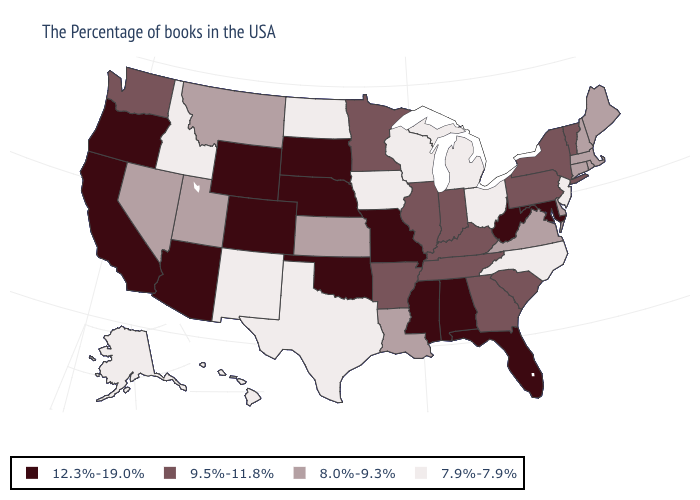What is the value of Wisconsin?
Answer briefly. 7.9%-7.9%. What is the value of North Dakota?
Short answer required. 7.9%-7.9%. Does Vermont have the highest value in the Northeast?
Give a very brief answer. Yes. Does California have a higher value than Maryland?
Keep it brief. No. What is the value of Indiana?
Answer briefly. 9.5%-11.8%. Name the states that have a value in the range 9.5%-11.8%?
Keep it brief. Vermont, New York, Pennsylvania, South Carolina, Georgia, Kentucky, Indiana, Tennessee, Illinois, Arkansas, Minnesota, Washington. How many symbols are there in the legend?
Keep it brief. 4. Does Colorado have the lowest value in the West?
Be succinct. No. Name the states that have a value in the range 12.3%-19.0%?
Give a very brief answer. Maryland, West Virginia, Florida, Alabama, Mississippi, Missouri, Nebraska, Oklahoma, South Dakota, Wyoming, Colorado, Arizona, California, Oregon. What is the value of West Virginia?
Short answer required. 12.3%-19.0%. Does Idaho have the same value as Virginia?
Write a very short answer. No. Does Vermont have the highest value in the Northeast?
Write a very short answer. Yes. Which states have the lowest value in the USA?
Give a very brief answer. New Jersey, North Carolina, Ohio, Michigan, Wisconsin, Iowa, Texas, North Dakota, New Mexico, Idaho, Alaska, Hawaii. Is the legend a continuous bar?
Be succinct. No. 